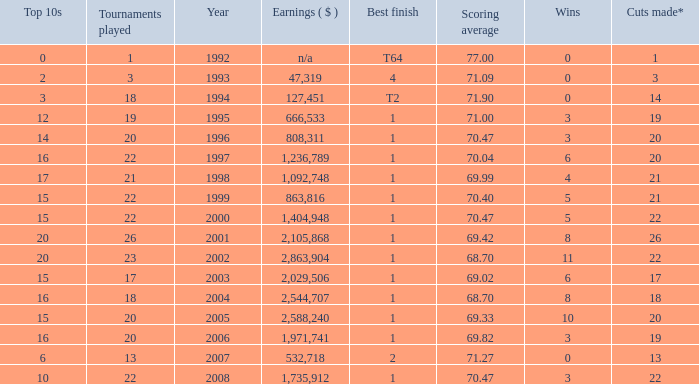Provide the maximum triumphs for years under 2000, optimal ending of 4, and events engaged in less than None. 